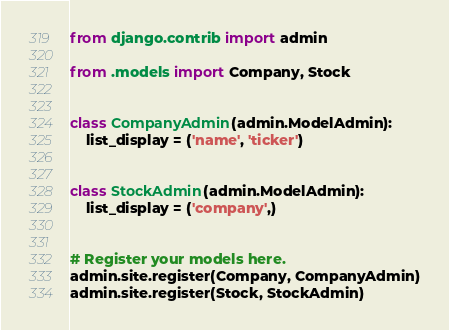Convert code to text. <code><loc_0><loc_0><loc_500><loc_500><_Python_>from django.contrib import admin

from .models import Company, Stock


class CompanyAdmin(admin.ModelAdmin):
    list_display = ('name', 'ticker')


class StockAdmin(admin.ModelAdmin):
    list_display = ('company',)


# Register your models here.
admin.site.register(Company, CompanyAdmin)
admin.site.register(Stock, StockAdmin)
</code> 